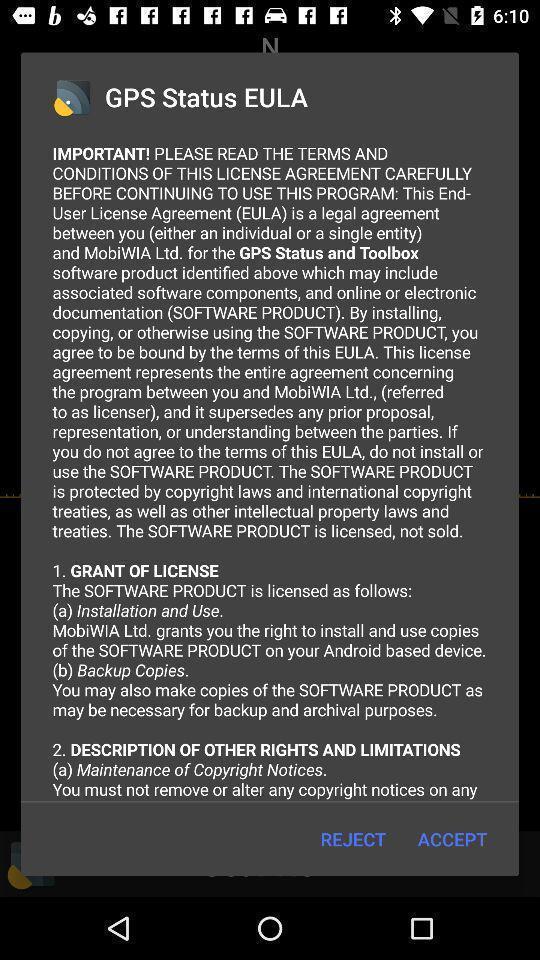What is the overall content of this screenshot? Pop-up displaying with agreement page of the application. 